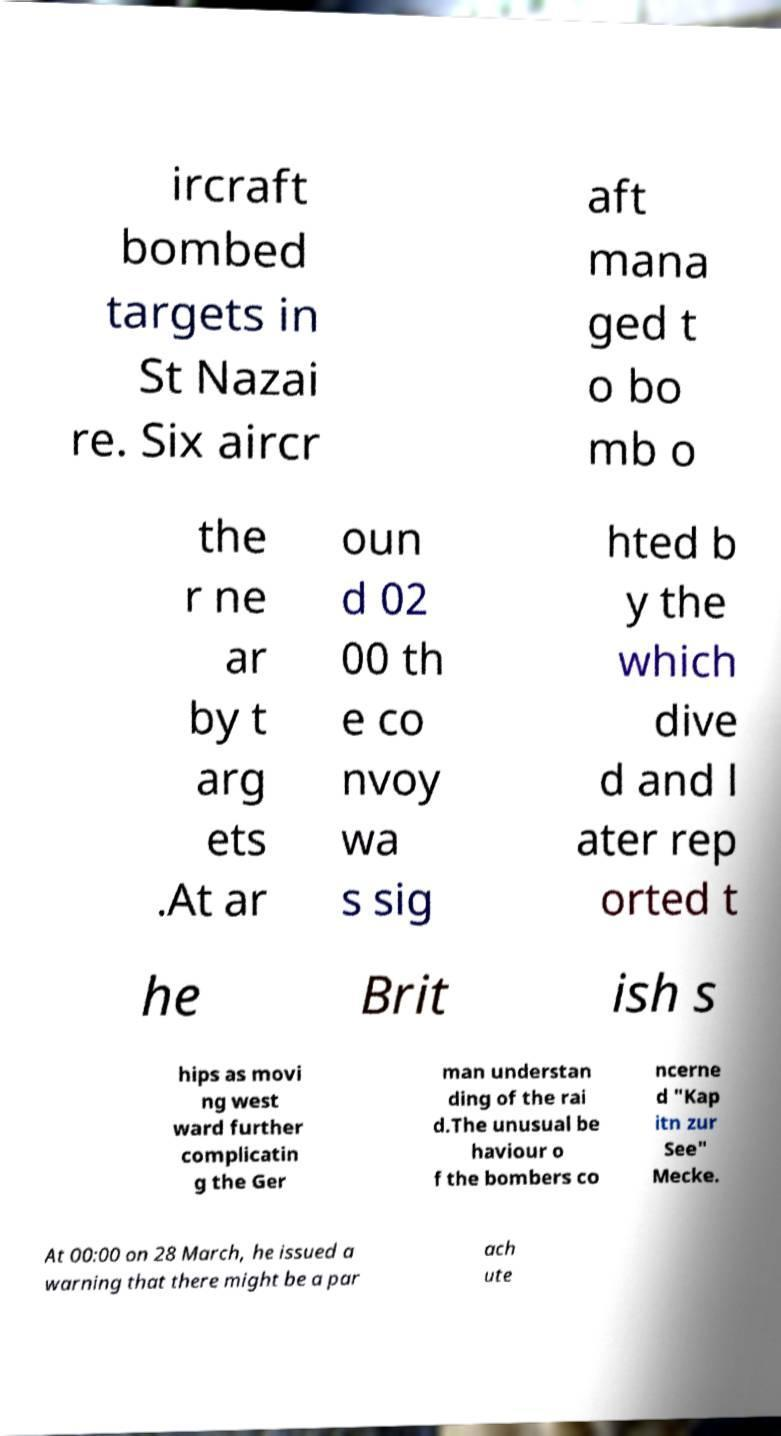Please read and relay the text visible in this image. What does it say? ircraft bombed targets in St Nazai re. Six aircr aft mana ged t o bo mb o the r ne ar by t arg ets .At ar oun d 02 00 th e co nvoy wa s sig hted b y the which dive d and l ater rep orted t he Brit ish s hips as movi ng west ward further complicatin g the Ger man understan ding of the rai d.The unusual be haviour o f the bombers co ncerne d "Kap itn zur See" Mecke. At 00:00 on 28 March, he issued a warning that there might be a par ach ute 